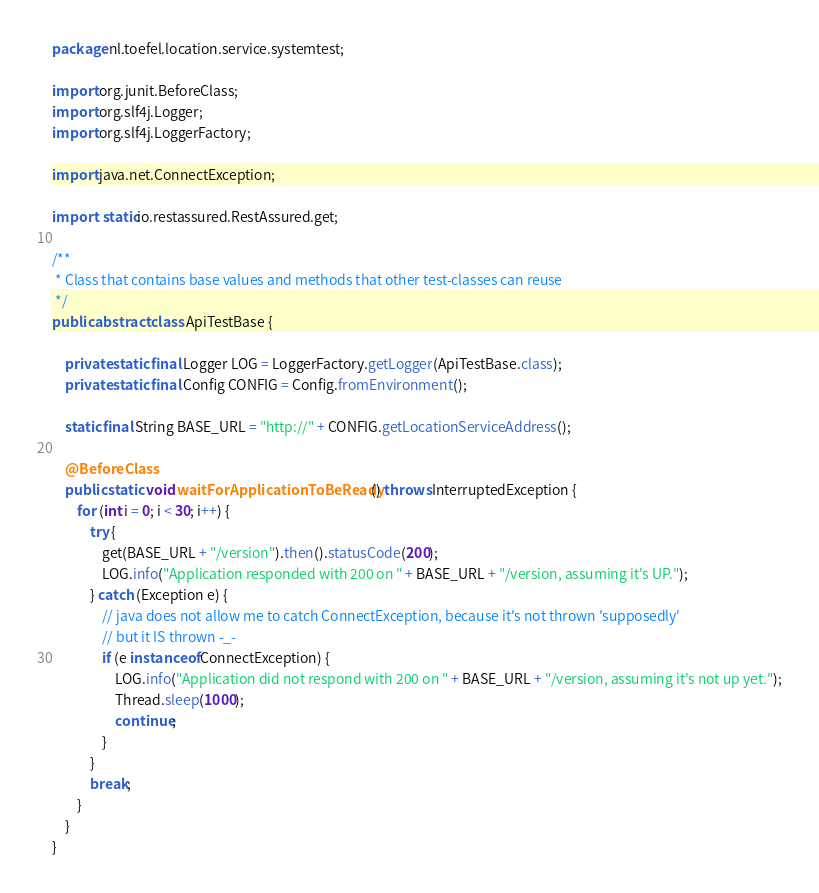<code> <loc_0><loc_0><loc_500><loc_500><_Java_>package nl.toefel.location.service.systemtest;

import org.junit.BeforeClass;
import org.slf4j.Logger;
import org.slf4j.LoggerFactory;

import java.net.ConnectException;

import static io.restassured.RestAssured.get;

/**
 * Class that contains base values and methods that other test-classes can reuse
 */
public abstract class ApiTestBase {

    private static final Logger LOG = LoggerFactory.getLogger(ApiTestBase.class);
    private static final Config CONFIG = Config.fromEnvironment();

    static final String BASE_URL = "http://" + CONFIG.getLocationServiceAddress();

    @BeforeClass
    public static void waitForApplicationToBeReady() throws InterruptedException {
        for (int i = 0; i < 30; i++) {
            try {
                get(BASE_URL + "/version").then().statusCode(200);
                LOG.info("Application responded with 200 on " + BASE_URL + "/version, assuming it's UP.");
            } catch (Exception e) {
                // java does not allow me to catch ConnectException, because it's not thrown 'supposedly'
                // but it IS thrown -_-
                if (e instanceof ConnectException) {
                    LOG.info("Application did not respond with 200 on " + BASE_URL + "/version, assuming it's not up yet.");
                    Thread.sleep(1000);
                    continue;
                }
            }
            break;
        }
    }
}
</code> 